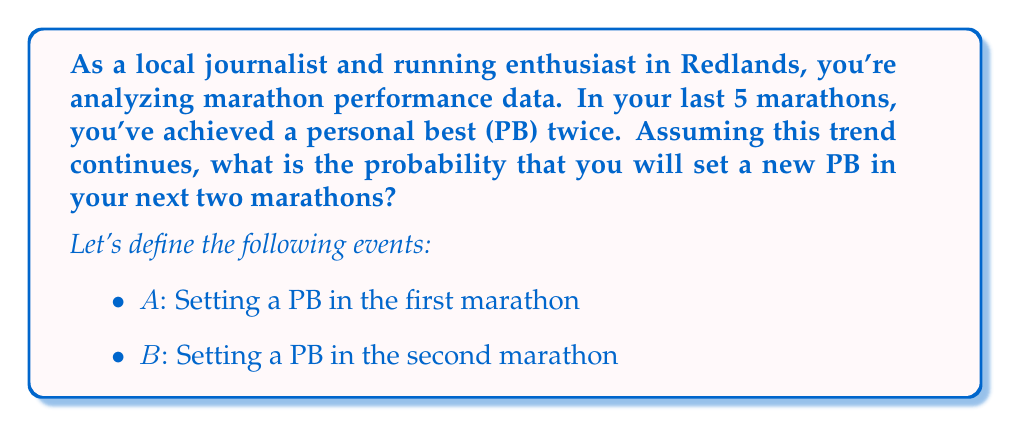Give your solution to this math problem. 1. Calculate the probability of setting a PB in a single marathon:
   $P(\text{PB in one race}) = \frac{\text{Number of PBs}}{\text{Total races}} = \frac{2}{5} = 0.4$

2. Probability of not setting a PB: $P(\text{No PB}) = 1 - 0.4 = 0.6$

3. To set a new PB in the next two marathons, we need at least one PB. Let's calculate the probability of not setting a PB in both races:
   $P(\text{No PB in both}) = 0.6 \times 0.6 = 0.36$

4. The probability of setting at least one PB is the complement of not setting a PB in both:
   $P(\text{At least one PB}) = 1 - P(\text{No PB in both}) = 1 - 0.36 = 0.64$

5. We can also calculate this using the addition rule of probability:
   $P(A \text{ or } B) = P(A) + P(B) - P(A \text{ and } B)$
   $= 0.4 + 0.4 - (0.4 \times 0.4) = 0.8 - 0.16 = 0.64$

Therefore, the probability of setting a new personal best in at least one of the next two marathons is 0.64 or 64%.
Answer: 0.64 